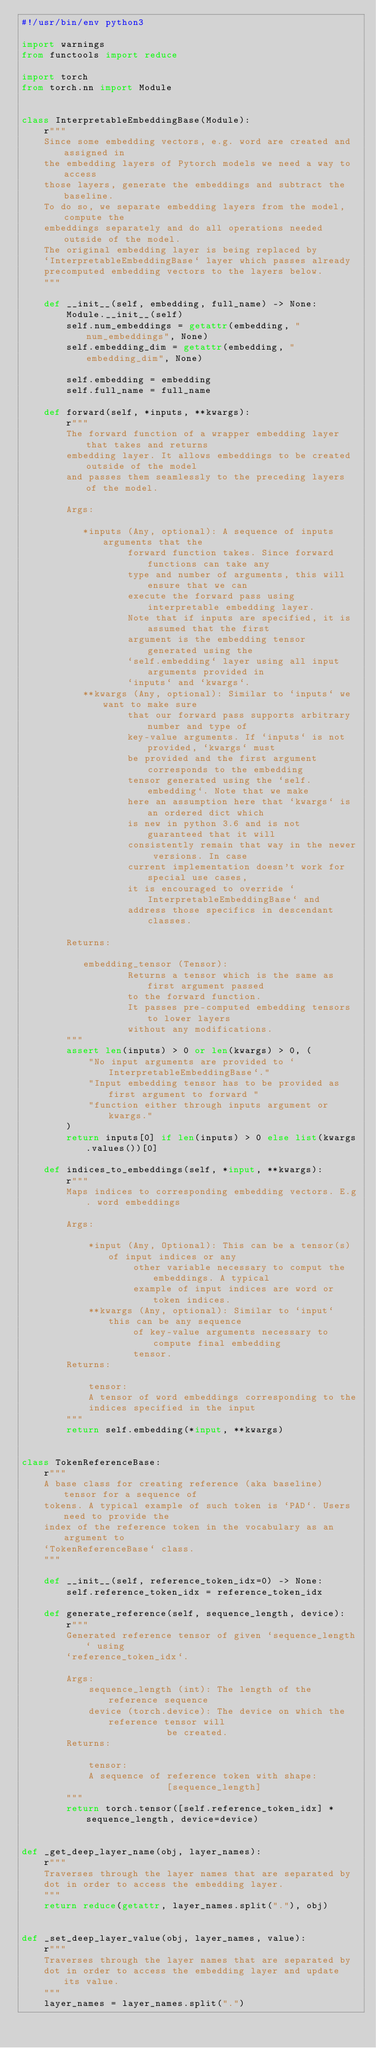<code> <loc_0><loc_0><loc_500><loc_500><_Python_>#!/usr/bin/env python3

import warnings
from functools import reduce

import torch
from torch.nn import Module


class InterpretableEmbeddingBase(Module):
    r"""
    Since some embedding vectors, e.g. word are created and assigned in
    the embedding layers of Pytorch models we need a way to access
    those layers, generate the embeddings and subtract the baseline.
    To do so, we separate embedding layers from the model, compute the
    embeddings separately and do all operations needed outside of the model.
    The original embedding layer is being replaced by
    `InterpretableEmbeddingBase` layer which passes already
    precomputed embedding vectors to the layers below.
    """

    def __init__(self, embedding, full_name) -> None:
        Module.__init__(self)
        self.num_embeddings = getattr(embedding, "num_embeddings", None)
        self.embedding_dim = getattr(embedding, "embedding_dim", None)

        self.embedding = embedding
        self.full_name = full_name

    def forward(self, *inputs, **kwargs):
        r"""
        The forward function of a wrapper embedding layer that takes and returns
        embedding layer. It allows embeddings to be created outside of the model
        and passes them seamlessly to the preceding layers of the model.

        Args:

           *inputs (Any, optional): A sequence of inputs arguments that the
                   forward function takes. Since forward functions can take any
                   type and number of arguments, this will ensure that we can
                   execute the forward pass using interpretable embedding layer.
                   Note that if inputs are specified, it is assumed that the first
                   argument is the embedding tensor generated using the
                   `self.embedding` layer using all input arguments provided in
                   `inputs` and `kwargs`.
           **kwargs (Any, optional): Similar to `inputs` we want to make sure
                   that our forward pass supports arbitrary number and type of
                   key-value arguments. If `inputs` is not provided, `kwargs` must
                   be provided and the first argument corresponds to the embedding
                   tensor generated using the `self.embedding`. Note that we make
                   here an assumption here that `kwargs` is an ordered dict which
                   is new in python 3.6 and is not guaranteed that it will
                   consistently remain that way in the newer versions. In case
                   current implementation doesn't work for special use cases,
                   it is encouraged to override `InterpretableEmbeddingBase` and
                   address those specifics in descendant classes.

        Returns:

           embedding_tensor (Tensor):
                   Returns a tensor which is the same as first argument passed
                   to the forward function.
                   It passes pre-computed embedding tensors to lower layers
                   without any modifications.
        """
        assert len(inputs) > 0 or len(kwargs) > 0, (
            "No input arguments are provided to `InterpretableEmbeddingBase`."
            "Input embedding tensor has to be provided as first argument to forward "
            "function either through inputs argument or kwargs."
        )
        return inputs[0] if len(inputs) > 0 else list(kwargs.values())[0]

    def indices_to_embeddings(self, *input, **kwargs):
        r"""
        Maps indices to corresponding embedding vectors. E.g. word embeddings

        Args:

            *input (Any, Optional): This can be a tensor(s) of input indices or any
                    other variable necessary to comput the embeddings. A typical
                    example of input indices are word or token indices.
            **kwargs (Any, optional): Similar to `input` this can be any sequence
                    of key-value arguments necessary to compute final embedding
                    tensor.
        Returns:

            tensor:
            A tensor of word embeddings corresponding to the
            indices specified in the input
        """
        return self.embedding(*input, **kwargs)


class TokenReferenceBase:
    r"""
    A base class for creating reference (aka baseline) tensor for a sequence of
    tokens. A typical example of such token is `PAD`. Users need to provide the
    index of the reference token in the vocabulary as an argument to
    `TokenReferenceBase` class.
    """

    def __init__(self, reference_token_idx=0) -> None:
        self.reference_token_idx = reference_token_idx

    def generate_reference(self, sequence_length, device):
        r"""
        Generated reference tensor of given `sequence_length` using
        `reference_token_idx`.

        Args:
            sequence_length (int): The length of the reference sequence
            device (torch.device): The device on which the reference tensor will
                          be created.
        Returns:

            tensor:
            A sequence of reference token with shape:
                          [sequence_length]
        """
        return torch.tensor([self.reference_token_idx] * sequence_length, device=device)


def _get_deep_layer_name(obj, layer_names):
    r"""
    Traverses through the layer names that are separated by
    dot in order to access the embedding layer.
    """
    return reduce(getattr, layer_names.split("."), obj)


def _set_deep_layer_value(obj, layer_names, value):
    r"""
    Traverses through the layer names that are separated by
    dot in order to access the embedding layer and update its value.
    """
    layer_names = layer_names.split(".")</code> 